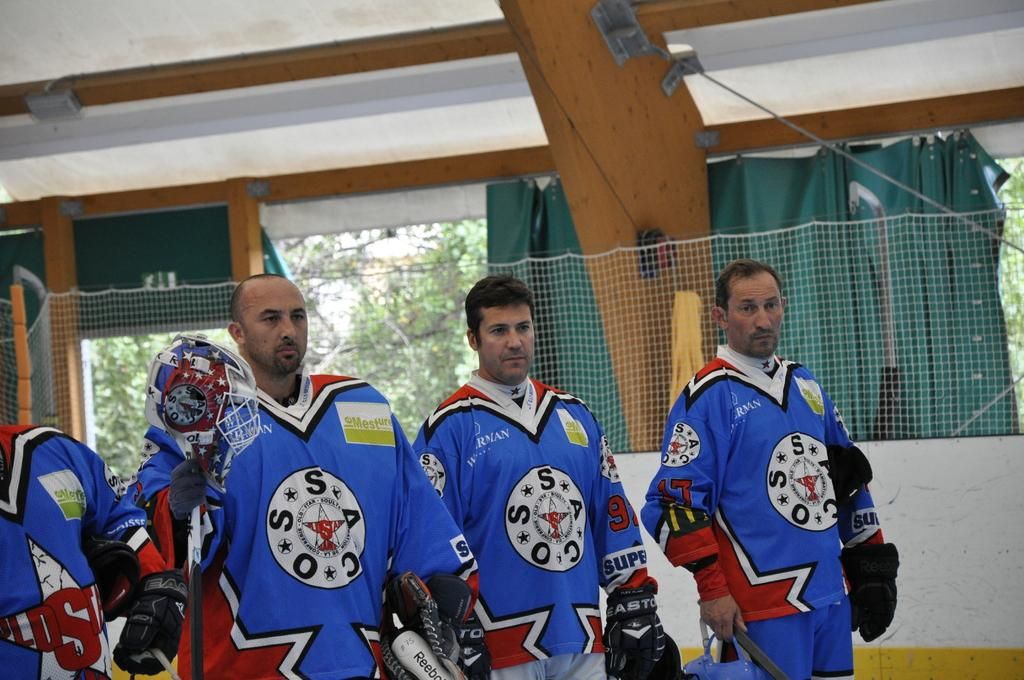<image>
Present a compact description of the photo's key features. Players with SSACO on their uniforms stand together. 